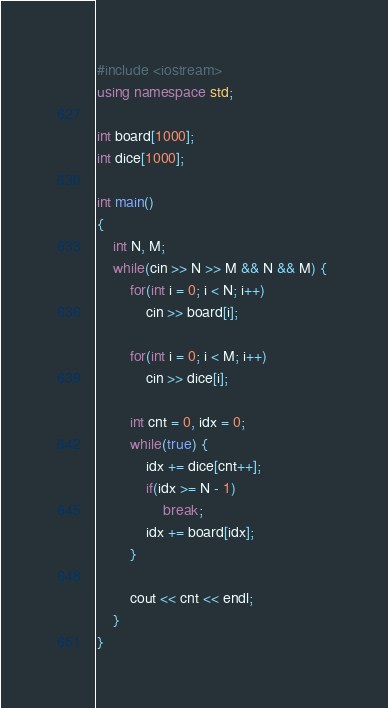Convert code to text. <code><loc_0><loc_0><loc_500><loc_500><_C++_>#include <iostream>
using namespace std;

int board[1000];
int dice[1000];

int main()
{
    int N, M;
    while(cin >> N >> M && N && M) { 
        for(int i = 0; i < N; i++) 
            cin >> board[i];

        for(int i = 0; i < M; i++)
            cin >> dice[i];

        int cnt = 0, idx = 0;
        while(true) {
            idx += dice[cnt++];
            if(idx >= N - 1)
                break;
            idx += board[idx];
        }
        
        cout << cnt << endl;
    }
}</code> 